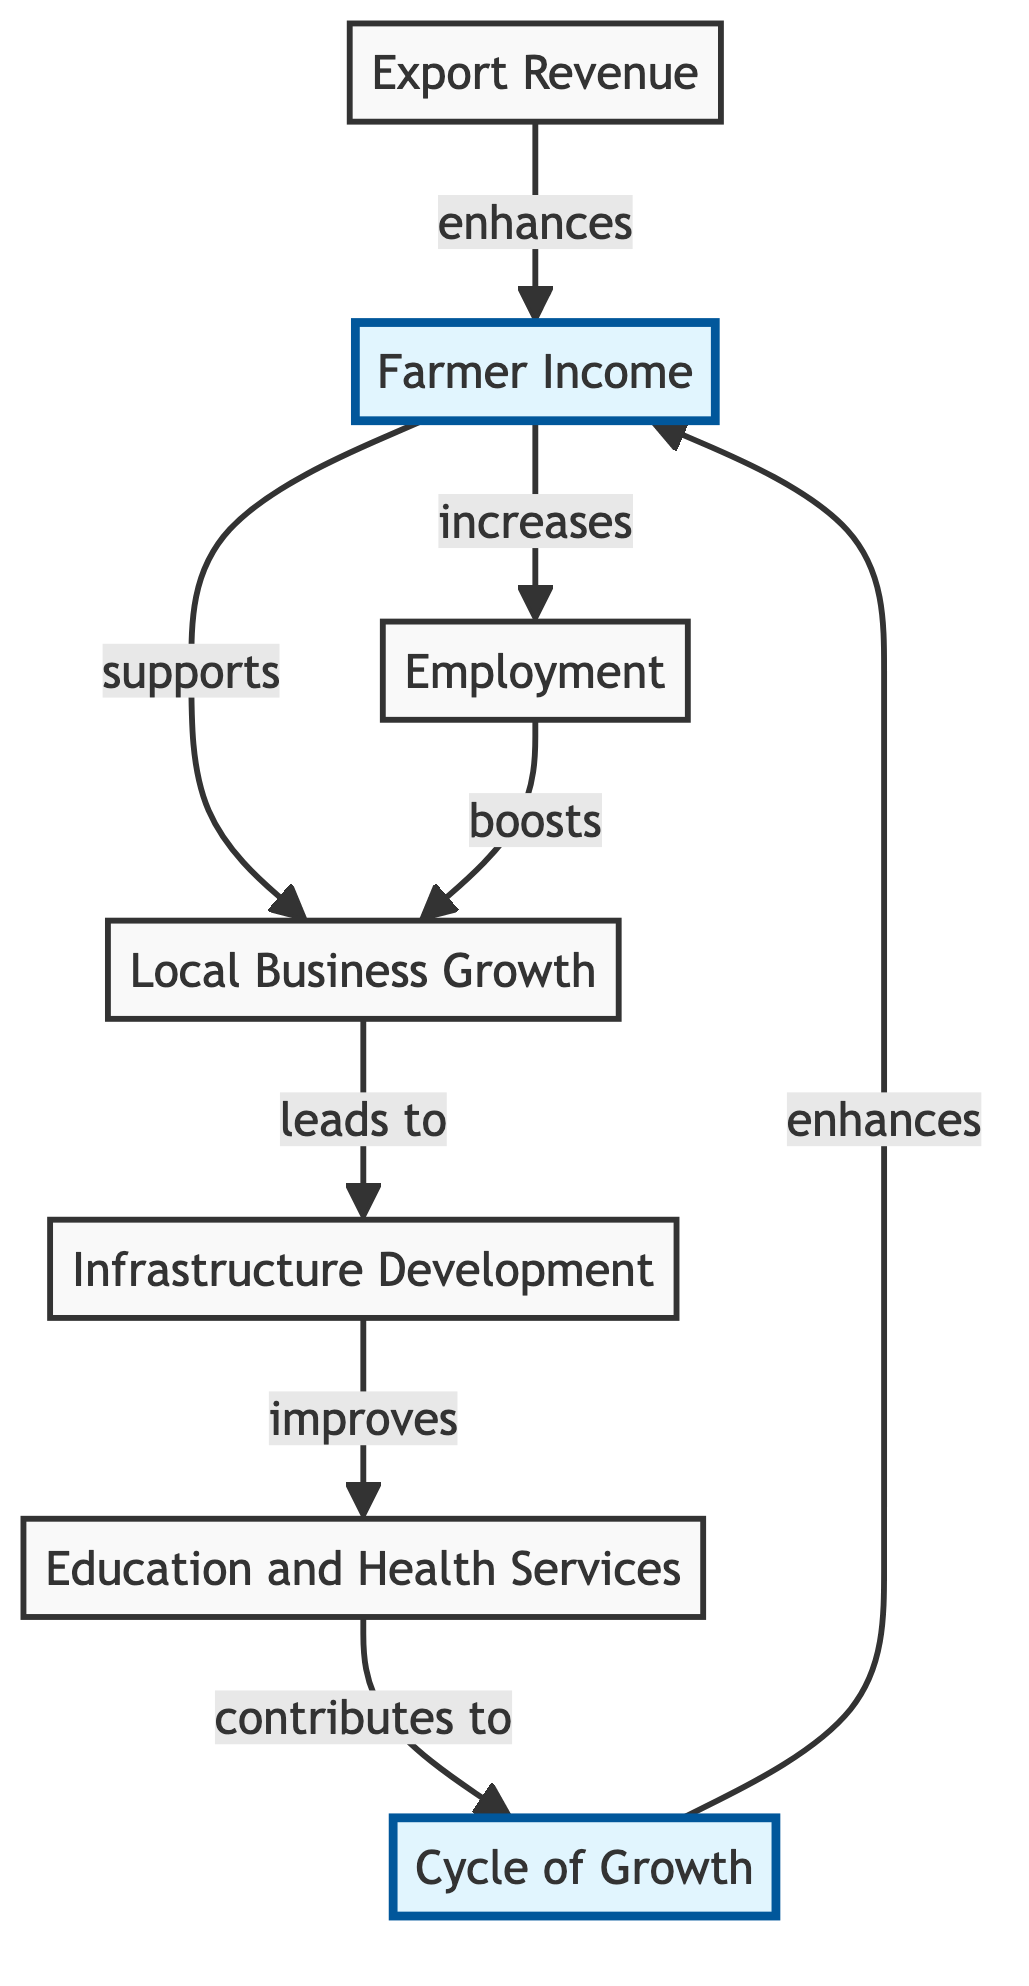What is the central node regarding the income generated in jute production? The central node showcasing the income impact from jute production is "Farmer Income," which is emphasized in the diagram.
Answer: Farmer Income How many main nodes are present in the diagram? The diagram contains a total of seven main nodes, including both the input and output nodes relating to the economic impact of jute production.
Answer: Seven What impact does "Farmer Income" have on "Employment"? According to the diagram, "Farmer Income" directly leads to an increase in "Employment," showing a positive relationship between them.
Answer: Increases What contributes to the improvement of "Education and Health Services"? "Infrastructure Development" is the key node that improves "Education and Health Services" as shown in the flow of impact within the diagram.
Answer: Infrastructure Development What cycle is indicated in the diagram that enhances "Farmer Income"? The cycle indicated is known as the "Cycle of Growth," which the diagram shows feeds back into "Farmer Income," enhancing its value over time.
Answer: Cycle of Growth How does "Export Revenue" influence the "Local Business Growth"? "Export Revenue" supports "Local Business Growth" as indicated in the diagram; this relationship illustrates how export activities can stimulate local economies.
Answer: Supports Which node highlights the primary advantage for farmers? The "Farmer Income" node is highlighted in the diagram as it represents the primary economic advantage for farmers resulting from jute production and its related activities.
Answer: Farmer Income 